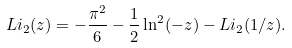<formula> <loc_0><loc_0><loc_500><loc_500>L i _ { 2 } ( z ) = - \frac { \pi ^ { 2 } } { 6 } - \frac { 1 } { 2 } \ln ^ { 2 } ( - z ) - L i _ { 2 } ( 1 / z ) .</formula> 